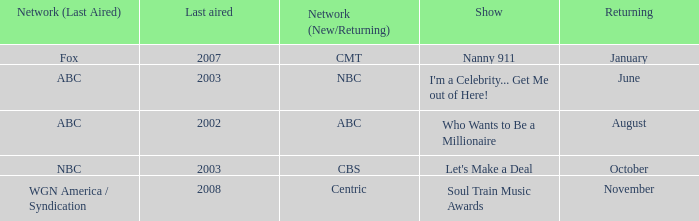When did a show last aired in 2002 return? August. 